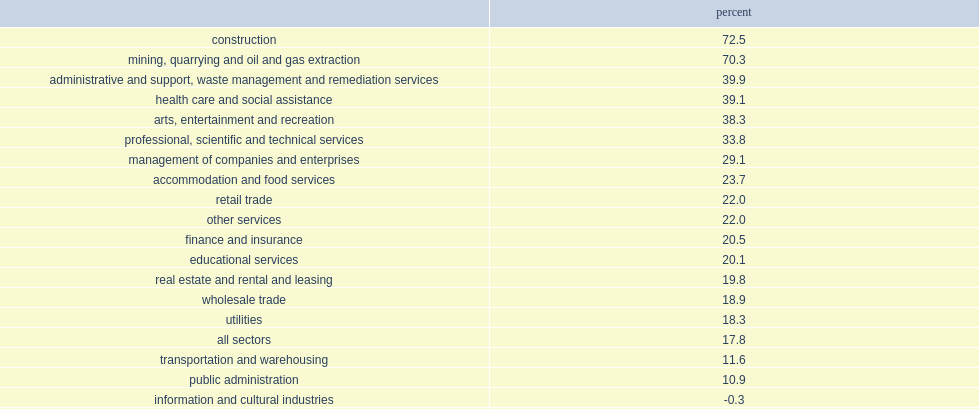What were the percentages of employment growth in the mining, quarrying, and oil and gas extraction sector and all sectors respectively? 70.3 17.8. 